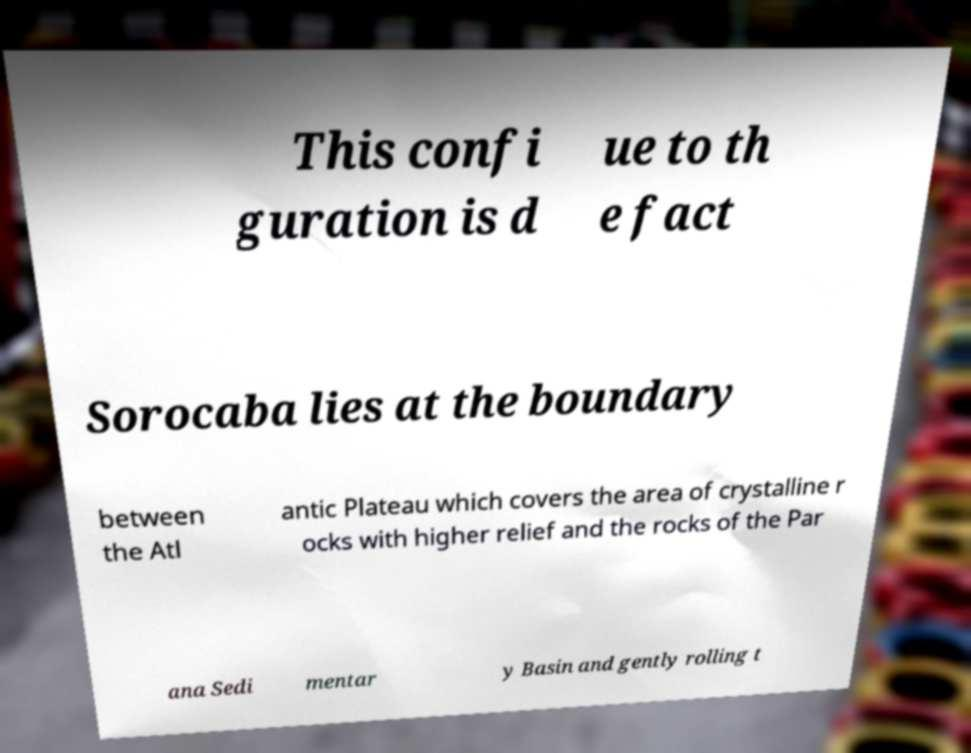Can you accurately transcribe the text from the provided image for me? This confi guration is d ue to th e fact Sorocaba lies at the boundary between the Atl antic Plateau which covers the area of crystalline r ocks with higher relief and the rocks of the Par ana Sedi mentar y Basin and gently rolling t 